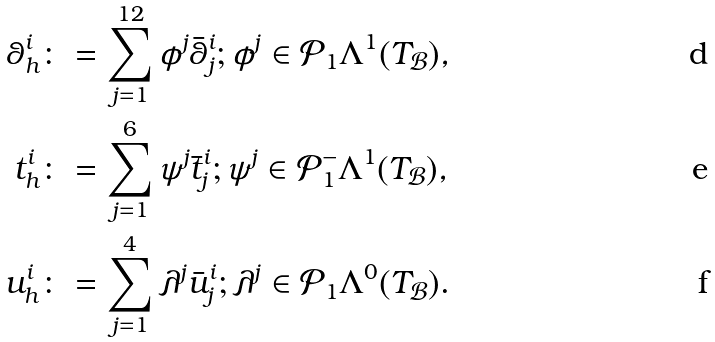<formula> <loc_0><loc_0><loc_500><loc_500>\theta ^ { i } _ { h } & \colon = \sum _ { j = 1 } ^ { 1 2 } \phi ^ { j } \bar { \theta } _ { j } ^ { i } ; \phi ^ { j } \in \mathcal { P } _ { 1 } \Lambda ^ { 1 } ( T _ { \mathcal { B } } ) , \\ t ^ { i } _ { h } & \colon = \sum _ { j = 1 } ^ { 6 } \psi ^ { j } \bar { t } _ { j } ^ { i } ; \psi ^ { j } \in \mathcal { P } _ { 1 } ^ { - } \Lambda ^ { 1 } ( T _ { \mathcal { B } } ) , \\ u ^ { i } _ { h } & \colon = \sum _ { j = 1 } ^ { 4 } \lambda ^ { j } \bar { u } ^ { i } _ { j } ; \lambda ^ { j } \in \mathcal { P } _ { 1 } \Lambda ^ { 0 } ( T _ { \mathcal { B } } ) .</formula> 